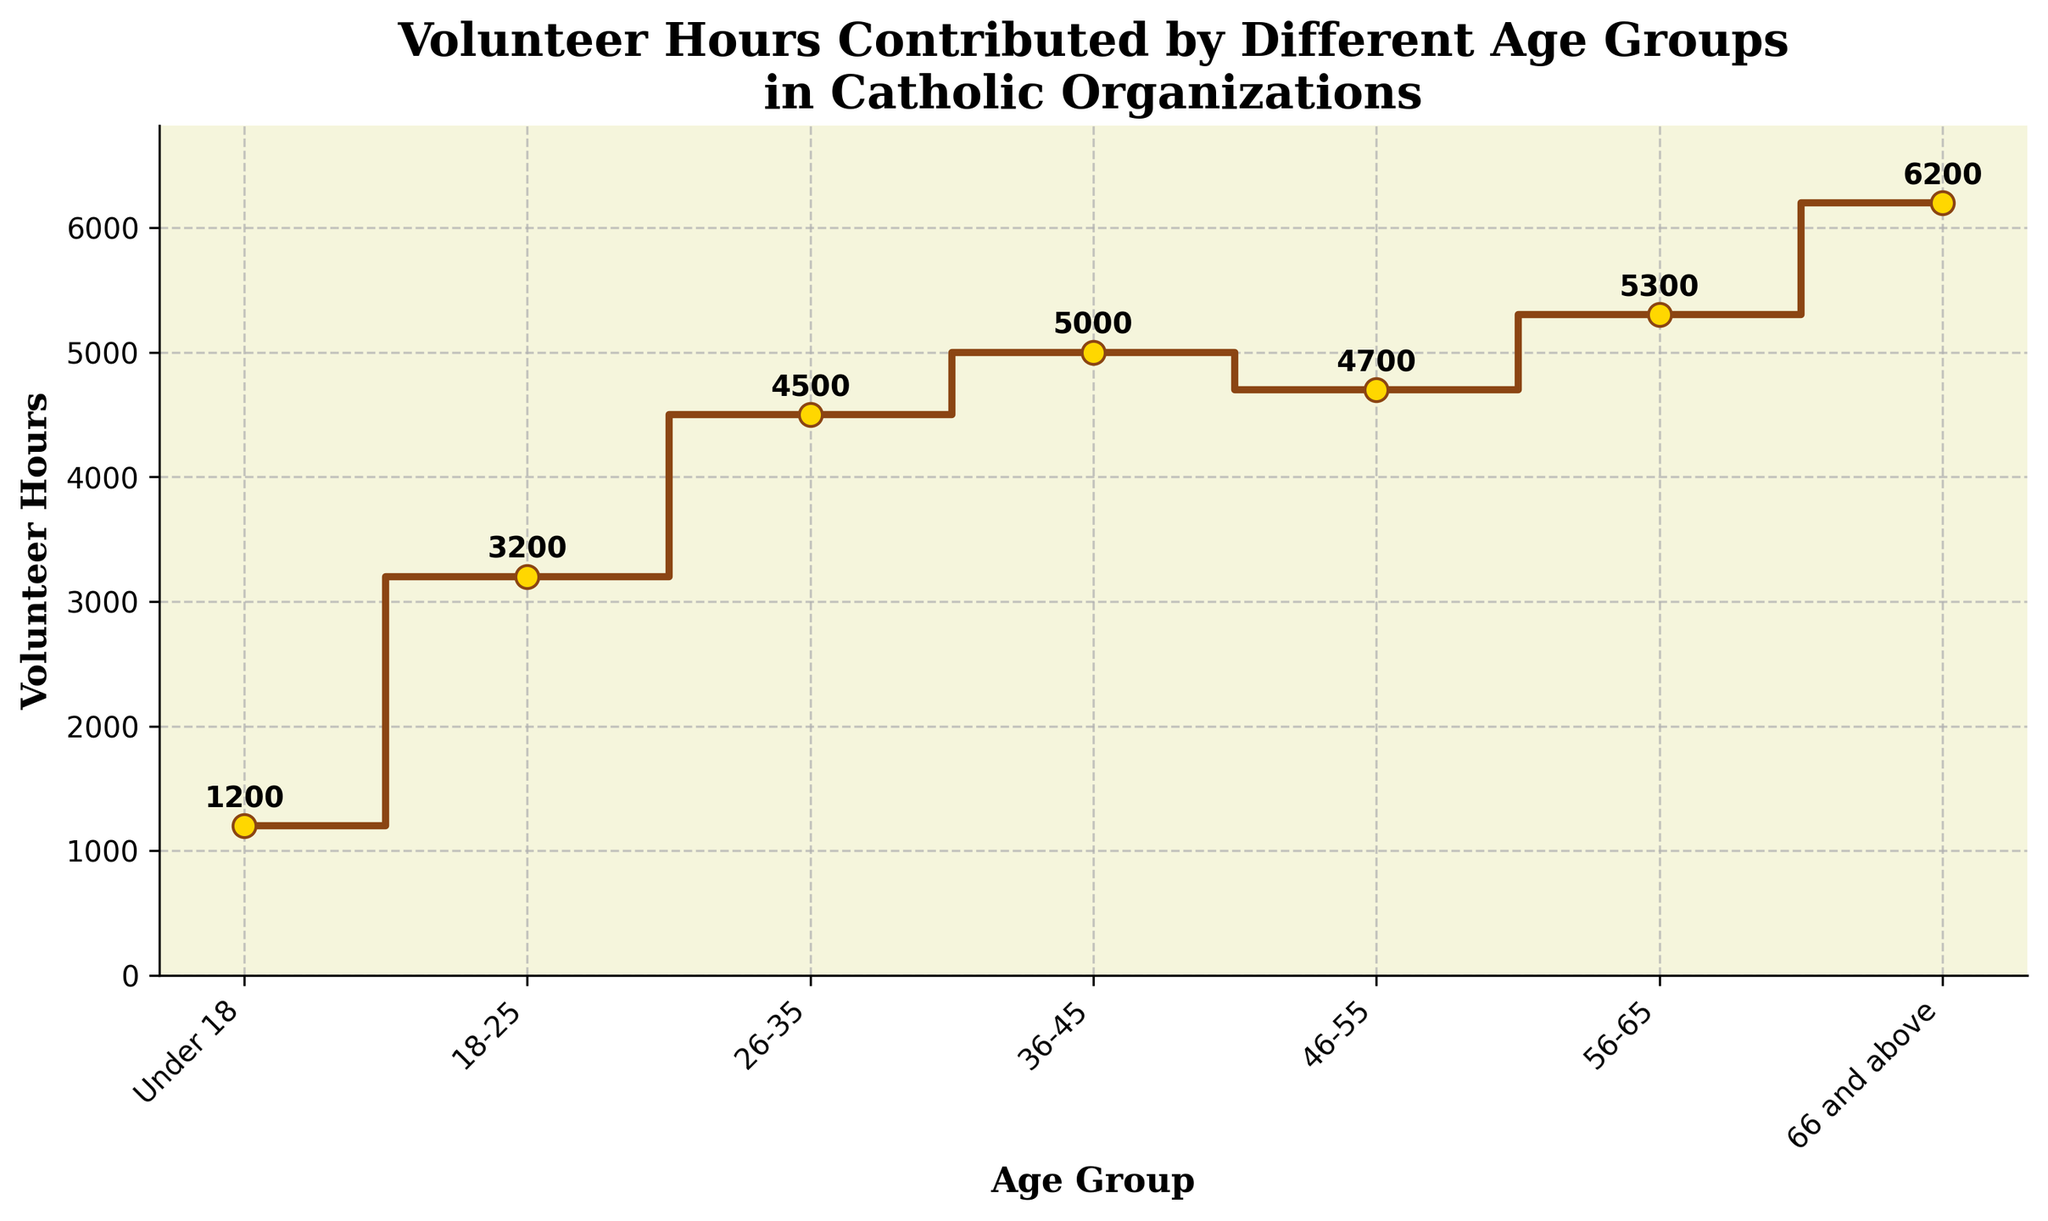Which age group contributes the highest number of volunteer hours? The age group of "66 and above" has the highest value on the y-axis in the plot.
Answer: 66 and above What is the total number of volunteer hours contributed by all age groups? Sum the values for each age group: 1200 + 3200 + 4500 + 5000 + 4700 + 5300 + 6200 = 30100
Answer: 30100 How many age groups are represented in the plot? Count the number of distinct categories on the x-axis.
Answer: 7 Which age group contributes fewer volunteer hours: "36-45" or "46-55"? Compare the values on the y-axis for these two age groups: 5000 (36-45) vs. 4700 (46-55).
Answer: 46-55 What is the difference in volunteer hours between the "Under 18" and "66 and above" age groups? Subtract the volunteer hours of "Under 18" from "66 and above": 6200 - 1200 = 5000
Answer: 5000 Which age groups have contributed more than 5000 volunteer hours? Identify the age groups with y-axis values greater than 5000: 56-65, 66 and above.
Answer: 56-65, 66 and above What is the average number of volunteer hours contributed by the age groups "18-25", "26-35", and "36-45"? Sum the values for these three groups and divide by 3: (3200 + 4500 + 5000) / 3 = 3900
Answer: 3900 What is the median volunteer hours contributed among all age groups? Order the volunteer hours and find the middle value: 1200, 3200, 4500, 4700, 5000, 5300, 6200. Median is 4700.
Answer: 4700 How does the trend of volunteer hours change with increasing age? Observe that the volunteer hours tend to increase overall with age, peaking at "66 and above" except for slight declines at "46-55" and a peak at "56-65".
Answer: Generally increases At which point does the step change occur between the greatest difference in volunteer hours between consecutive age groups? Identify the largest difference between adjacent volunteer hours values: between "Under 18" and "18-25" (3200 - 1200 = 2000).
Answer: Between "Under 18" and "18-25" 